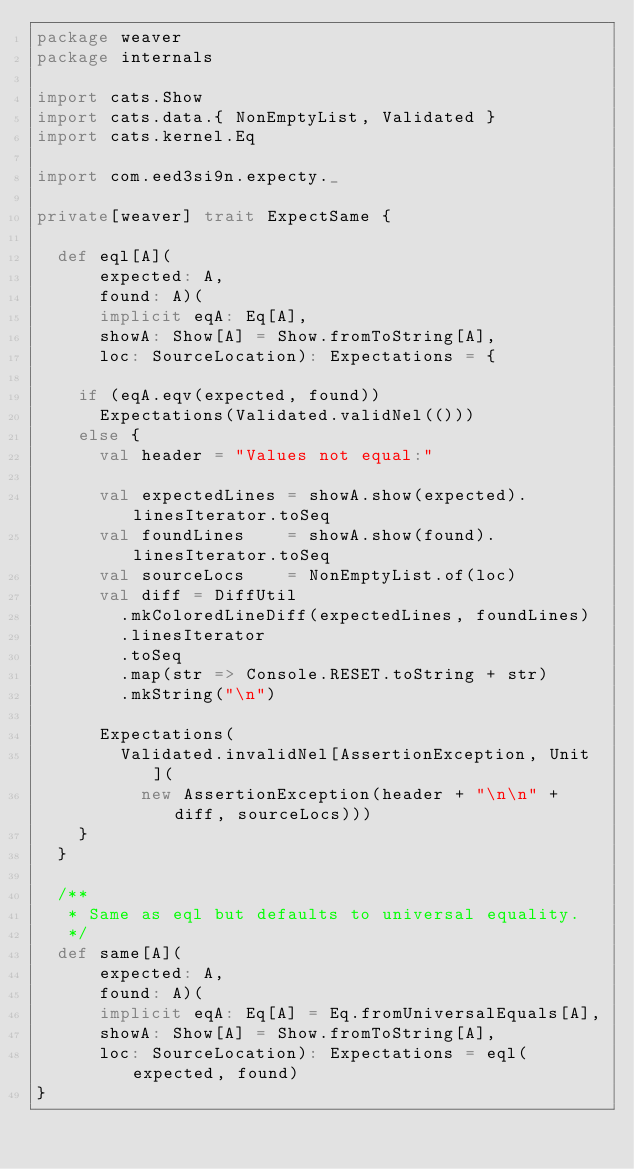Convert code to text. <code><loc_0><loc_0><loc_500><loc_500><_Scala_>package weaver
package internals

import cats.Show
import cats.data.{ NonEmptyList, Validated }
import cats.kernel.Eq

import com.eed3si9n.expecty._

private[weaver] trait ExpectSame {

  def eql[A](
      expected: A,
      found: A)(
      implicit eqA: Eq[A],
      showA: Show[A] = Show.fromToString[A],
      loc: SourceLocation): Expectations = {

    if (eqA.eqv(expected, found))
      Expectations(Validated.validNel(()))
    else {
      val header = "Values not equal:"

      val expectedLines = showA.show(expected).linesIterator.toSeq
      val foundLines    = showA.show(found).linesIterator.toSeq
      val sourceLocs    = NonEmptyList.of(loc)
      val diff = DiffUtil
        .mkColoredLineDiff(expectedLines, foundLines)
        .linesIterator
        .toSeq
        .map(str => Console.RESET.toString + str)
        .mkString("\n")

      Expectations(
        Validated.invalidNel[AssertionException, Unit](
          new AssertionException(header + "\n\n" + diff, sourceLocs)))
    }
  }

  /**
   * Same as eql but defaults to universal equality.
   */
  def same[A](
      expected: A,
      found: A)(
      implicit eqA: Eq[A] = Eq.fromUniversalEquals[A],
      showA: Show[A] = Show.fromToString[A],
      loc: SourceLocation): Expectations = eql(expected, found)
}
</code> 